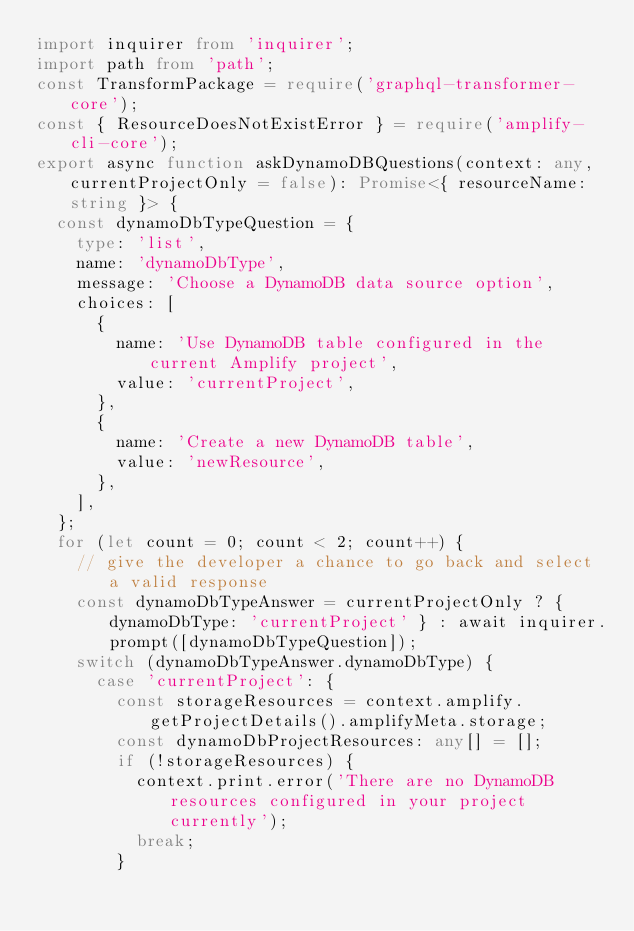<code> <loc_0><loc_0><loc_500><loc_500><_TypeScript_>import inquirer from 'inquirer';
import path from 'path';
const TransformPackage = require('graphql-transformer-core');
const { ResourceDoesNotExistError } = require('amplify-cli-core');
export async function askDynamoDBQuestions(context: any, currentProjectOnly = false): Promise<{ resourceName: string }> {
  const dynamoDbTypeQuestion = {
    type: 'list',
    name: 'dynamoDbType',
    message: 'Choose a DynamoDB data source option',
    choices: [
      {
        name: 'Use DynamoDB table configured in the current Amplify project',
        value: 'currentProject',
      },
      {
        name: 'Create a new DynamoDB table',
        value: 'newResource',
      },
    ],
  };
  for (let count = 0; count < 2; count++) {
    // give the developer a chance to go back and select a valid response
    const dynamoDbTypeAnswer = currentProjectOnly ? { dynamoDbType: 'currentProject' } : await inquirer.prompt([dynamoDbTypeQuestion]);
    switch (dynamoDbTypeAnswer.dynamoDbType) {
      case 'currentProject': {
        const storageResources = context.amplify.getProjectDetails().amplifyMeta.storage;
        const dynamoDbProjectResources: any[] = [];
        if (!storageResources) {
          context.print.error('There are no DynamoDB resources configured in your project currently');
          break;
        }</code> 